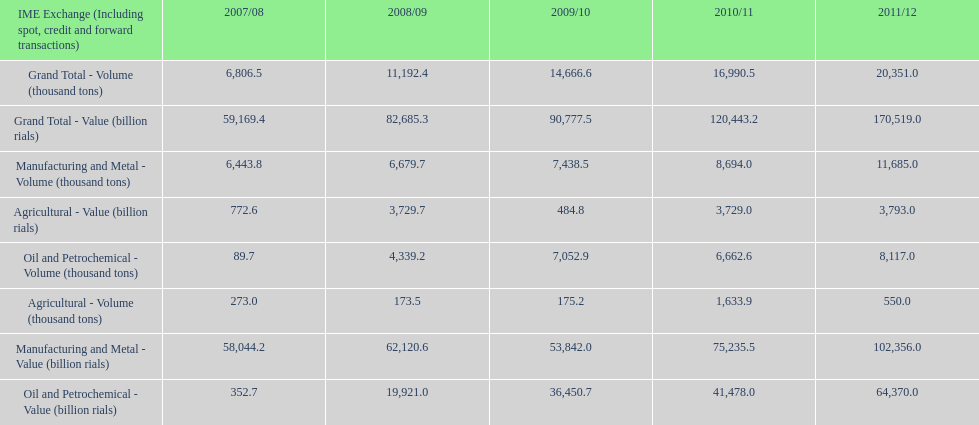Did 2010/11 or 2011/12 make more in grand total value? 2011/12. 